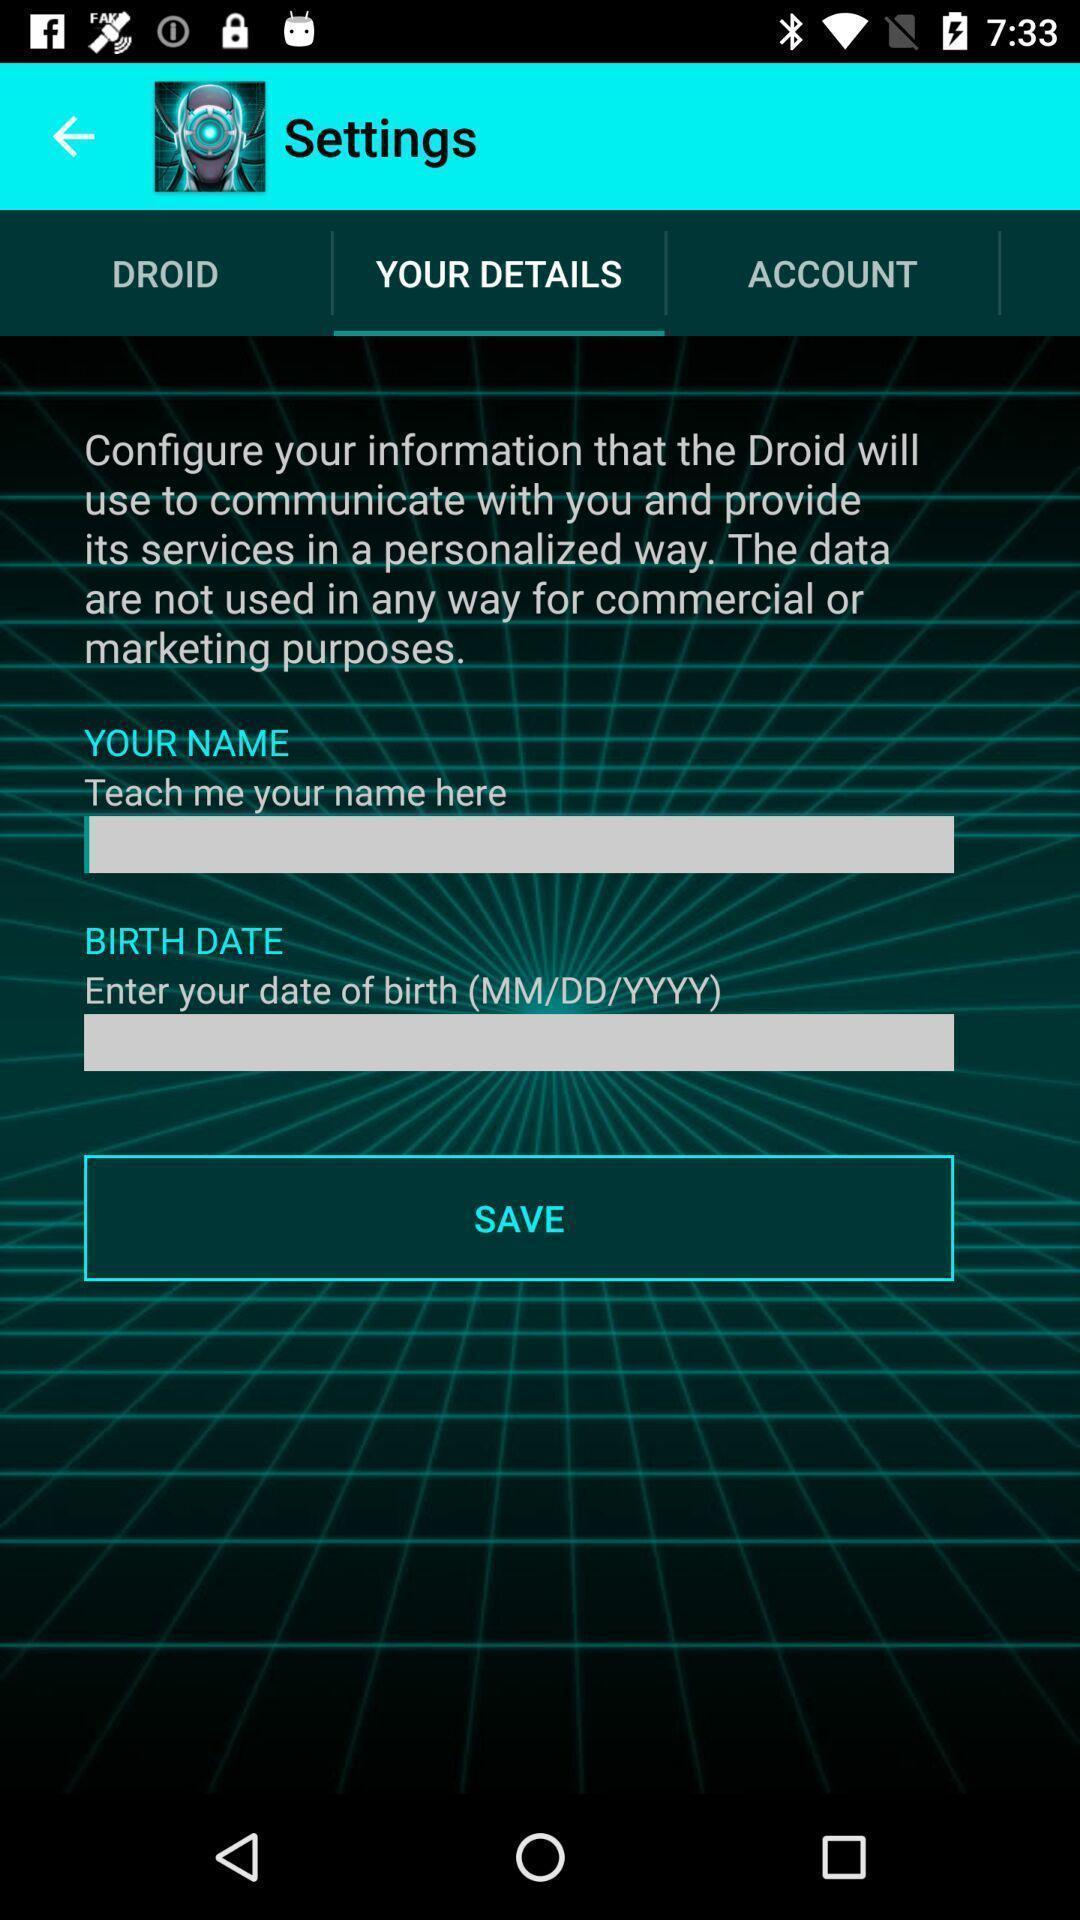Give me a summary of this screen capture. Screen shows user details option in settings. 